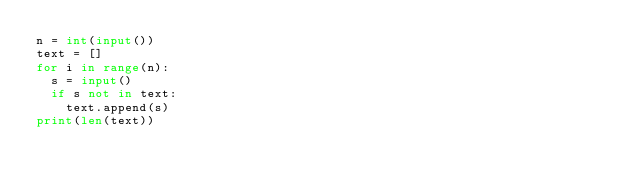Convert code to text. <code><loc_0><loc_0><loc_500><loc_500><_Python_>n = int(input())
text = []
for i in range(n):
  s = input()
  if s not in text:
    text.append(s)
print(len(text))</code> 